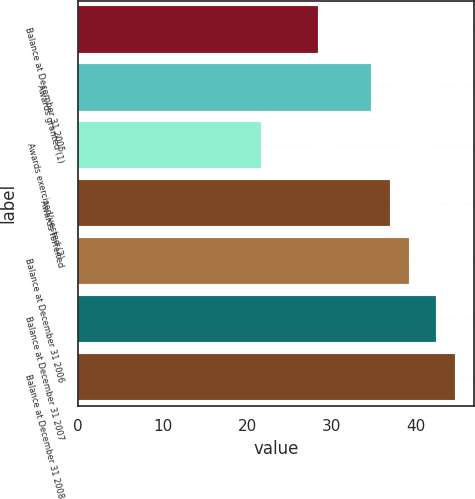Convert chart. <chart><loc_0><loc_0><loc_500><loc_500><bar_chart><fcel>Balance at December 31 2005<fcel>Awards granted (1)<fcel>Awards exercised/vested (2)<fcel>Awards forfeited<fcel>Balance at December 31 2006<fcel>Balance at December 31 2007<fcel>Balance at December 31 2008<nl><fcel>28.42<fcel>34.65<fcel>21.63<fcel>36.9<fcel>39.15<fcel>42.3<fcel>44.55<nl></chart> 